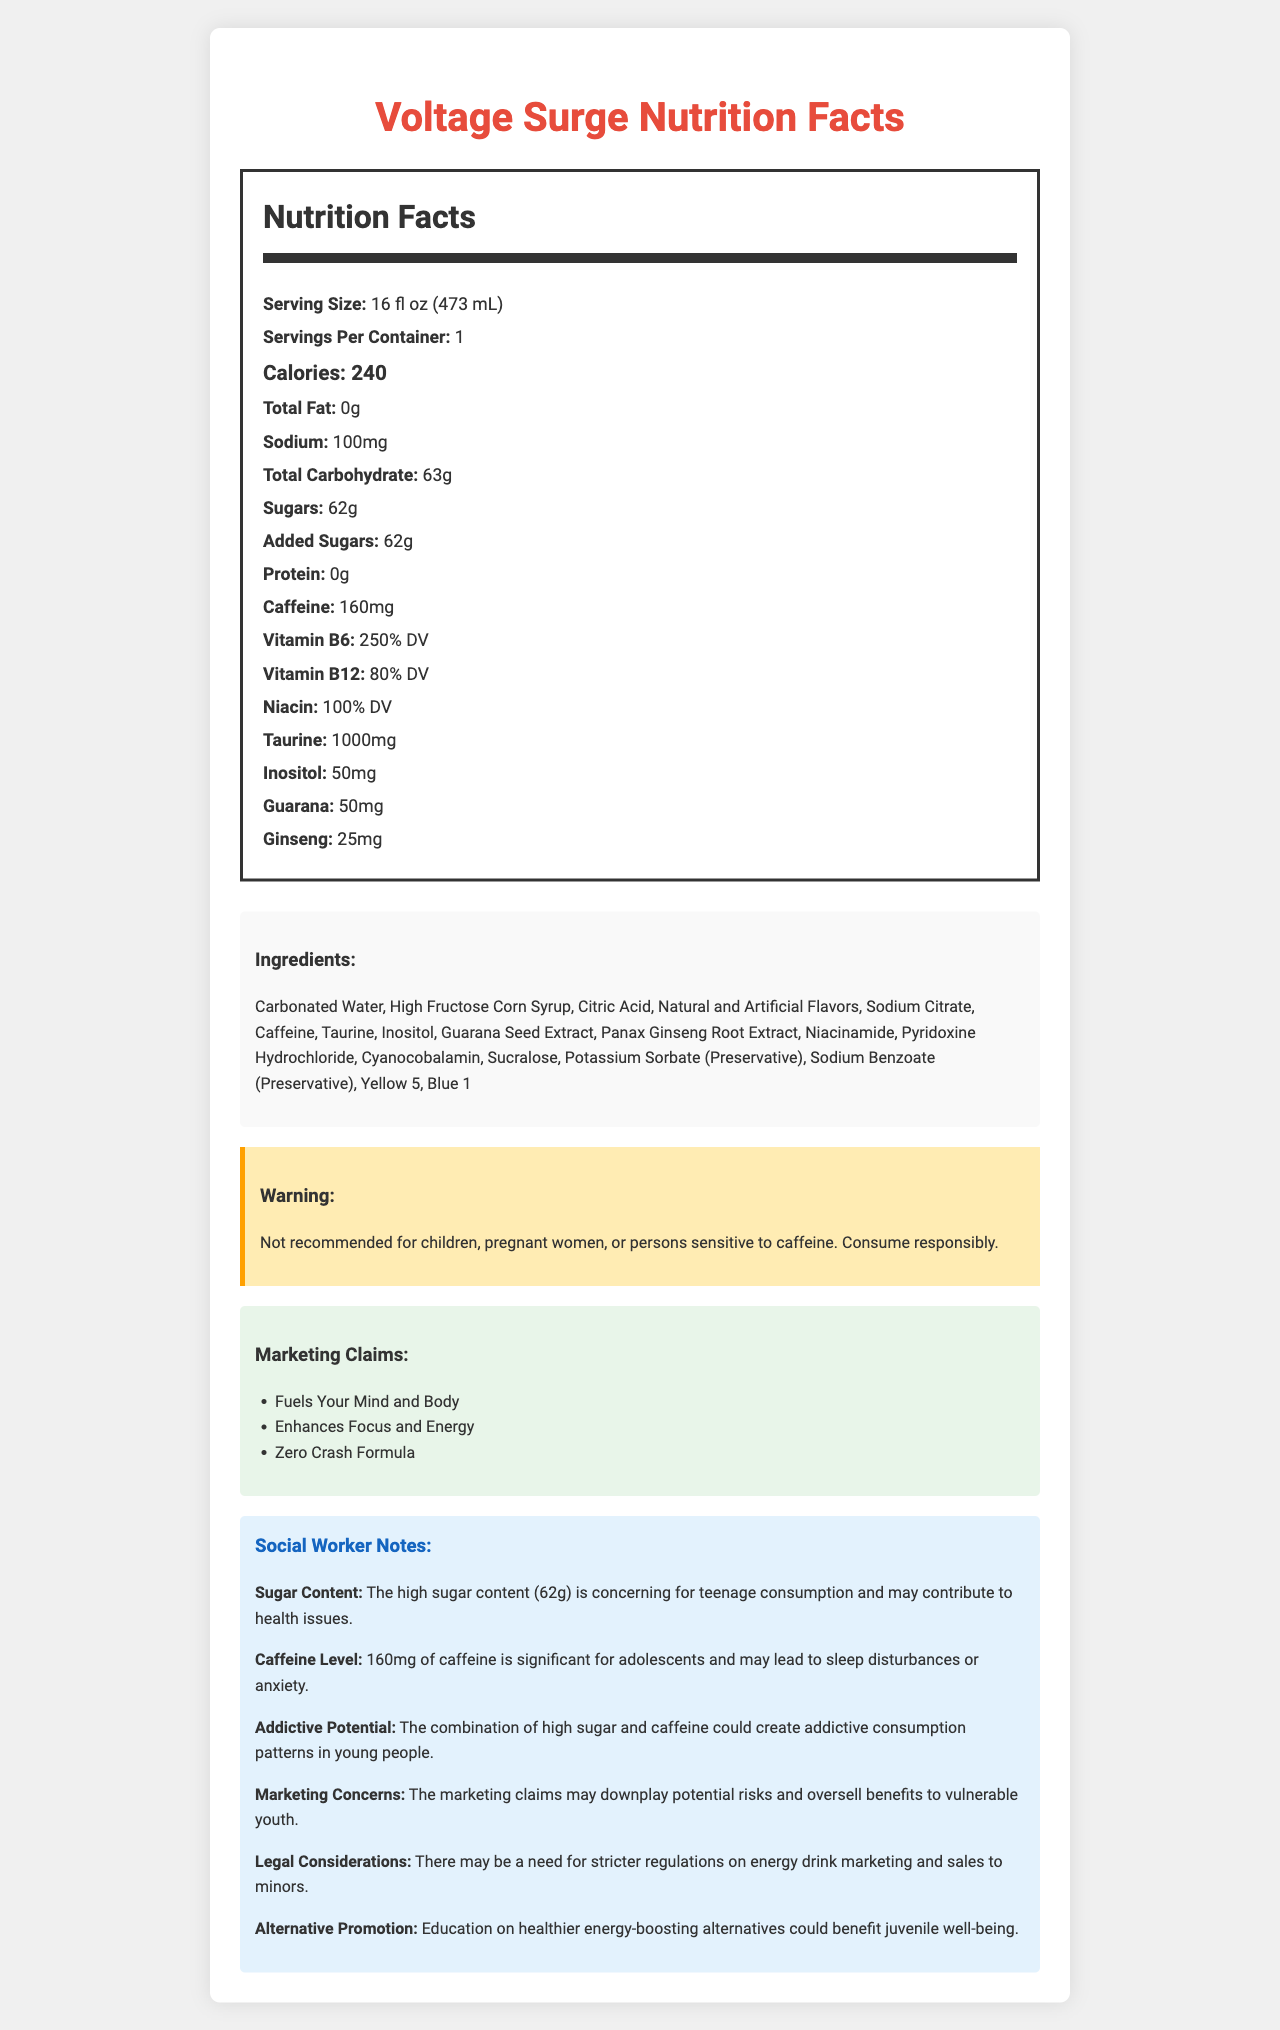what is the serving size of Voltage Surge? The serving size is listed as 16 fl oz (473 mL) under the Nutrition Facts section.
Answer: 16 fl oz (473 mL) how many calories are in one serving of Voltage Surge? The Nutrition Facts label shows that there are 240 calories per serving.
Answer: 240 how much caffeine does Voltage Surge contain? The document notes that Voltage Surge contains 160 mg of caffeine.
Answer: 160 mg what are the marketing claims made by Voltage Surge? These claims are listed under the Marketing Claims section in the document.
Answer: Fuels Your Mind and Body, Enhances Focus and Energy, Zero Crash Formula what is the main concern about the sugar content according to the social worker notes? This concern is explicitly stated in the social worker notes on sugar content.
Answer: The high sugar content (62g) is concerning for teenage consumption and may contribute to health issues. which of the following is NOT an ingredient of Voltage Surge? A. Potassium Sorbate B. Sucralose C. Ascorbic Acid D. Blue 1 Ascorbic Acid is not listed under the Ingredients section; the other options are ingredients in the drink.
Answer: C. Ascorbic Acid which vitamin has the highest daily value percentage in Voltage Surge? A. Vitamin B6 B. Vitamin B12 C. Niacin D. Vitamin C Vitamin B6 has a daily value of 250%, the highest among the listed vitamins.
Answer: A. Vitamin B6 does Voltage Surge contain protein? The Nutrition Facts section states that there is 0g of protein in Voltage Surge.
Answer: No should Voltage Surge be consumed by pregnant women? The warning statement advises against consumption by pregnant women.
Answer: No summarize the main points covered in the document. The document outlines the nutritional content, ingredient list, warnings, marketing claims, and social worker notes about Voltage Surge, emphasizing health risks and marketing concerns.
Answer: The document provides detailed nutrition information, ingredients, warnings, and marketing claims for Voltage Surge, an energy drink. It highlights the drink's high caffeine and sugar content, notes concerning teenage consumption, and includes social worker insights on health risks and marketing tactics. what is the exact percentage of daily value for Vitamin C in Voltage Surge? The document does not provide any information about Vitamin C.
Answer: Cannot be determined 